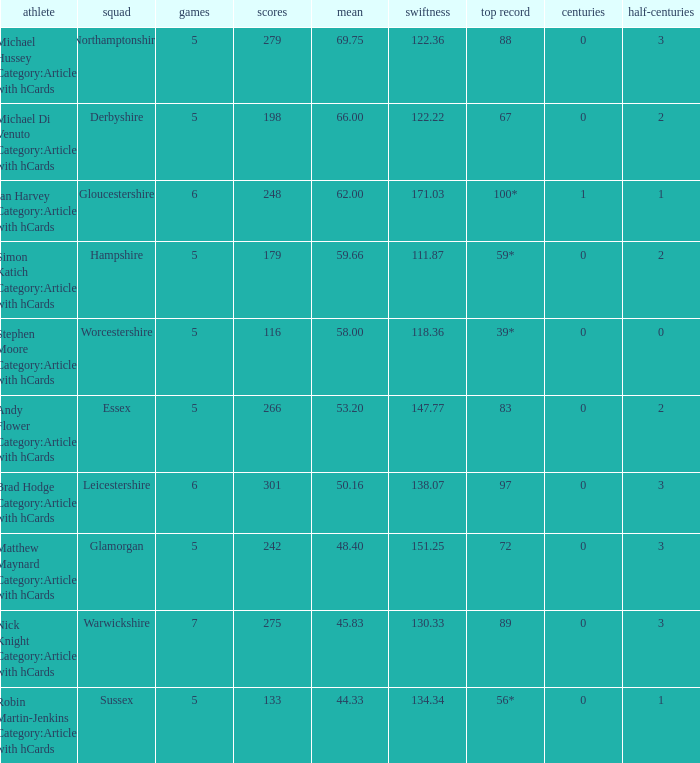What is the team Sussex' highest score? 56*. 